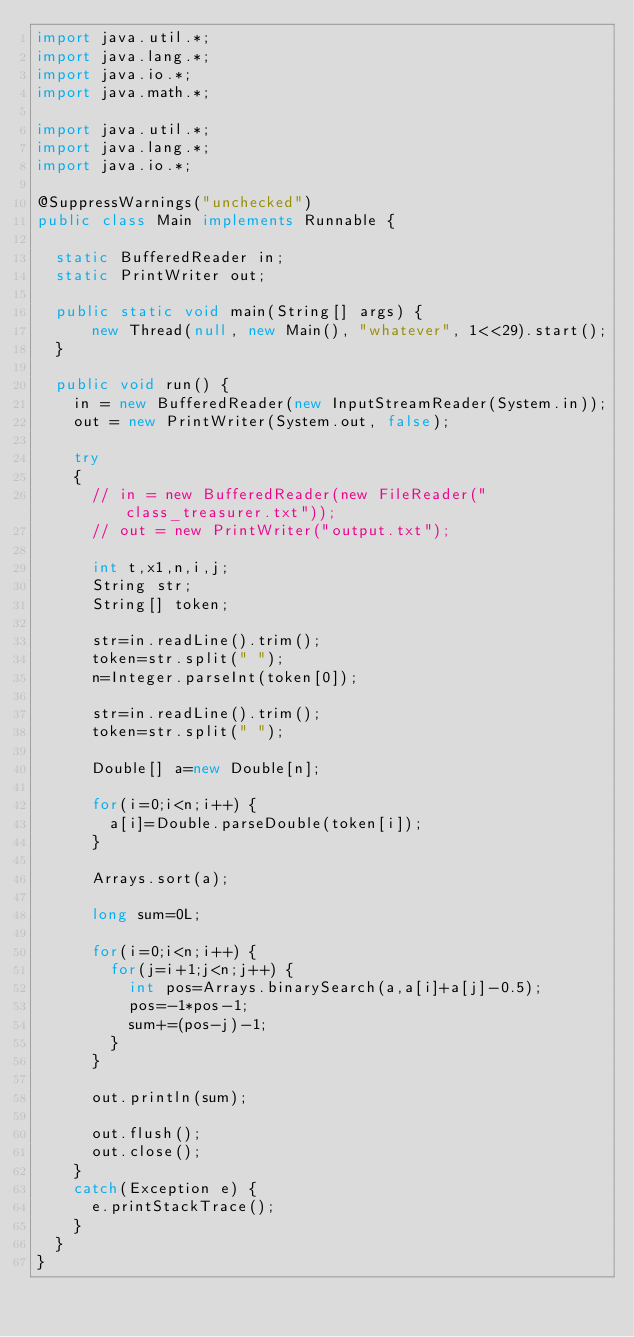Convert code to text. <code><loc_0><loc_0><loc_500><loc_500><_Java_>import java.util.*;
import java.lang.*;
import java.io.*;
import java.math.*;
 
import java.util.*;
import java.lang.*;
import java.io.*;

@SuppressWarnings("unchecked")
public class Main implements Runnable {

  static BufferedReader in;
  static PrintWriter out;
 
  public static void main(String[] args) {
      new Thread(null, new Main(), "whatever", 1<<29).start();
  }
 
  public void run() {
    in = new BufferedReader(new InputStreamReader(System.in));
    out = new PrintWriter(System.out, false);
 
    try
    {
      // in = new BufferedReader(new FileReader("class_treasurer.txt"));
      // out = new PrintWriter("output.txt");

      int t,x1,n,i,j;
      String str;
      String[] token;

      str=in.readLine().trim();
      token=str.split(" ");
      n=Integer.parseInt(token[0]);

      str=in.readLine().trim();
      token=str.split(" ");

      Double[] a=new Double[n];

      for(i=0;i<n;i++) {
        a[i]=Double.parseDouble(token[i]);
      }

      Arrays.sort(a);

      long sum=0L;

      for(i=0;i<n;i++) {
        for(j=i+1;j<n;j++) {
          int pos=Arrays.binarySearch(a,a[i]+a[j]-0.5);
          pos=-1*pos-1;
          sum+=(pos-j)-1;
        }
      }

      out.println(sum);

      out.flush();
      out.close();
    }
    catch(Exception e) {
      e.printStackTrace();
    }
  }
}
</code> 